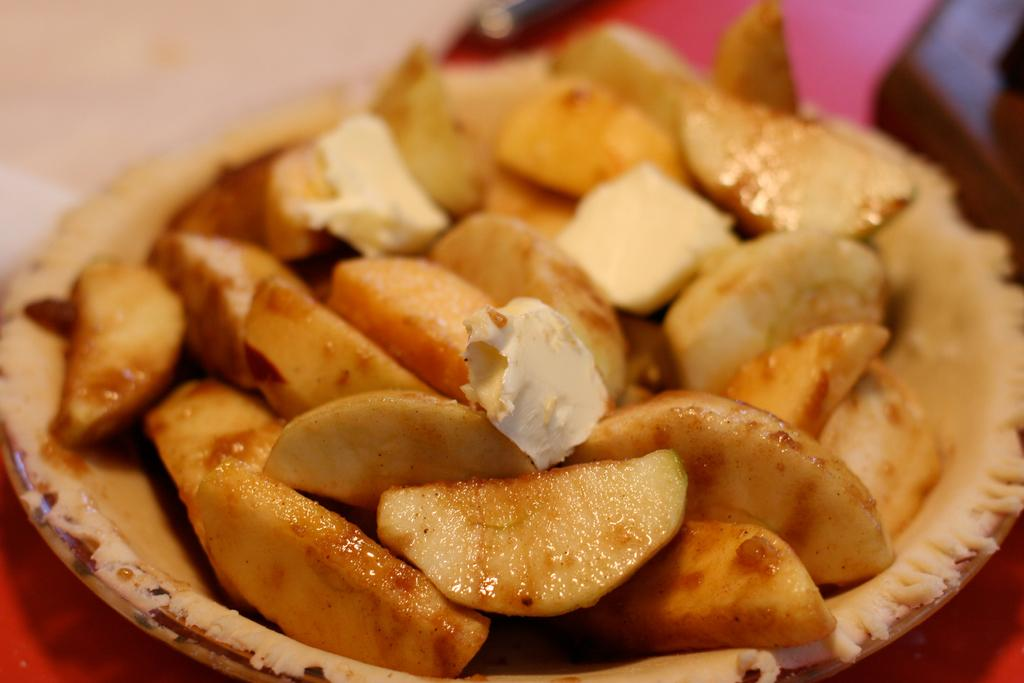What is present in the image? There is a bowl in the image. What is inside the bowl? The bowl contains a food item. Can you describe the background of the image? The background of the image is blurred. What arithmetic problem is being solved on the spoon in the image? There is no spoon present in the image, and no arithmetic problem is being solved. 